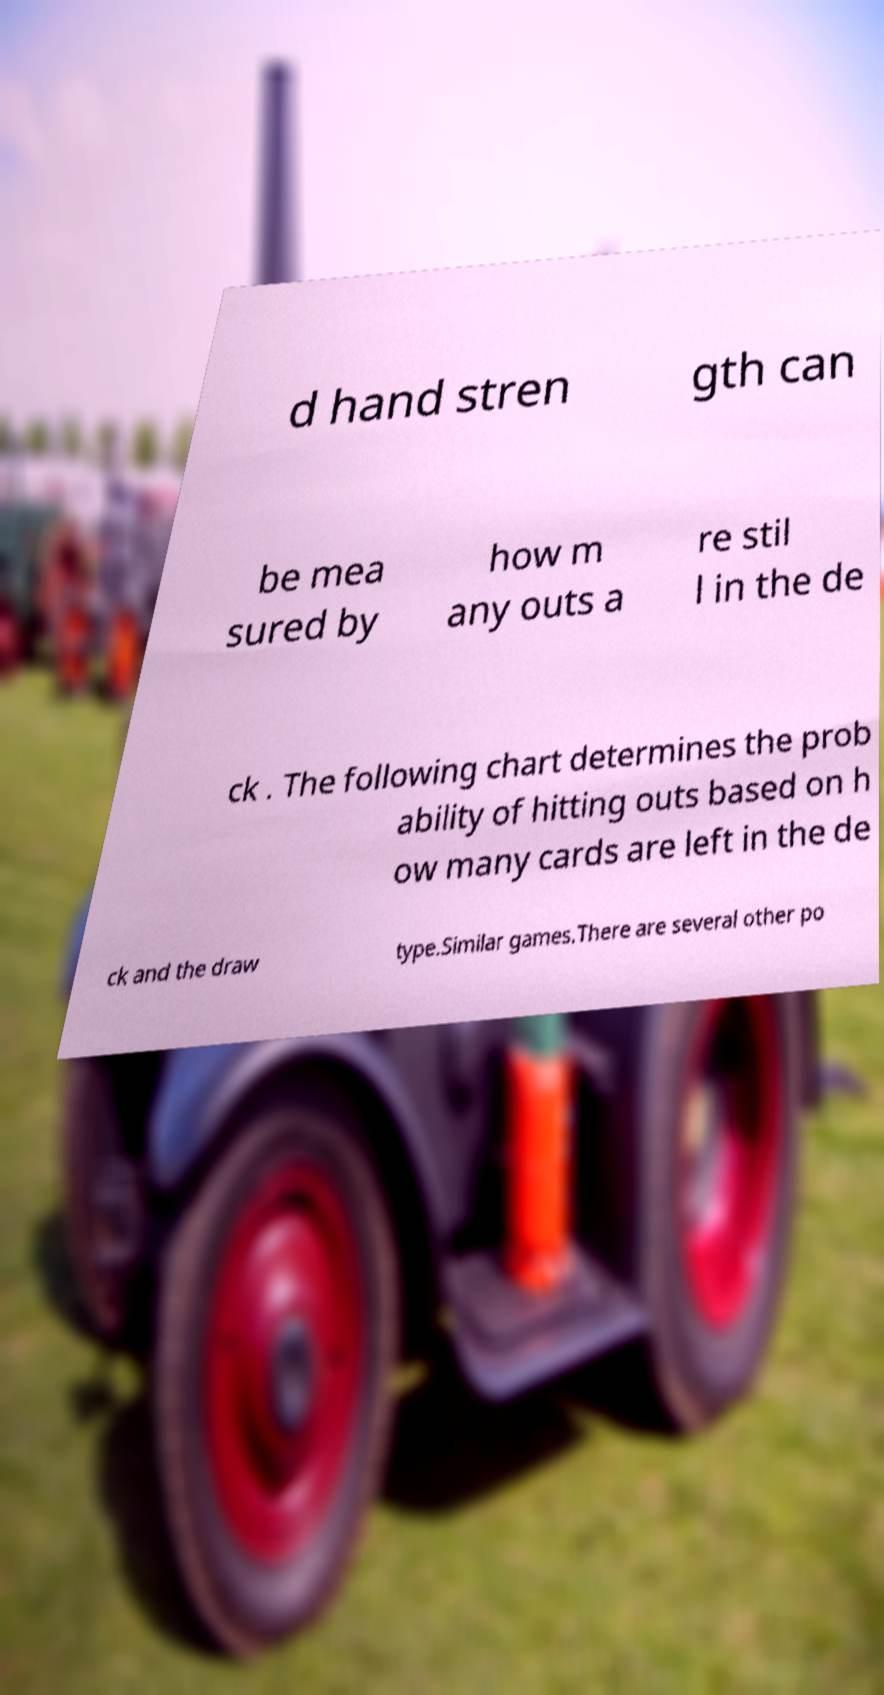Can you read and provide the text displayed in the image?This photo seems to have some interesting text. Can you extract and type it out for me? d hand stren gth can be mea sured by how m any outs a re stil l in the de ck . The following chart determines the prob ability of hitting outs based on h ow many cards are left in the de ck and the draw type.Similar games.There are several other po 